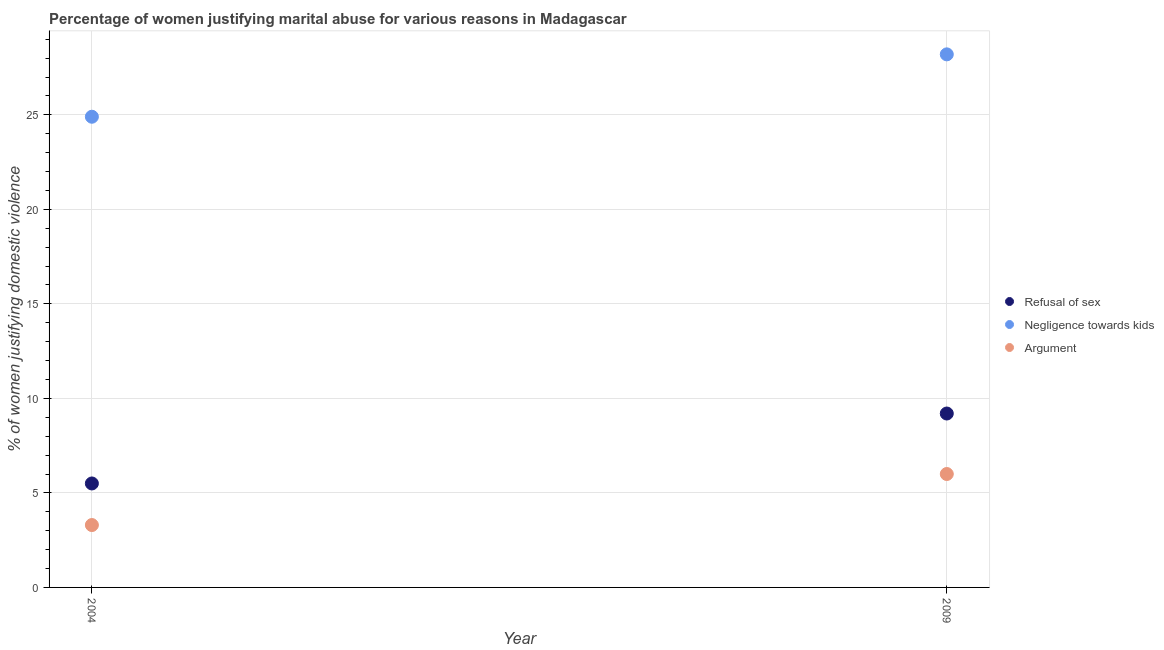How many different coloured dotlines are there?
Keep it short and to the point. 3. Is the number of dotlines equal to the number of legend labels?
Your answer should be very brief. Yes. What is the percentage of women justifying domestic violence due to arguments in 2004?
Offer a terse response. 3.3. Across all years, what is the minimum percentage of women justifying domestic violence due to refusal of sex?
Provide a short and direct response. 5.5. In which year was the percentage of women justifying domestic violence due to negligence towards kids minimum?
Provide a succinct answer. 2004. What is the total percentage of women justifying domestic violence due to negligence towards kids in the graph?
Provide a short and direct response. 53.1. What is the difference between the percentage of women justifying domestic violence due to negligence towards kids in 2004 and that in 2009?
Provide a succinct answer. -3.3. What is the average percentage of women justifying domestic violence due to negligence towards kids per year?
Offer a terse response. 26.55. In the year 2004, what is the difference between the percentage of women justifying domestic violence due to arguments and percentage of women justifying domestic violence due to negligence towards kids?
Give a very brief answer. -21.6. In how many years, is the percentage of women justifying domestic violence due to arguments greater than 23 %?
Ensure brevity in your answer.  0. What is the ratio of the percentage of women justifying domestic violence due to negligence towards kids in 2004 to that in 2009?
Provide a short and direct response. 0.88. Is the percentage of women justifying domestic violence due to refusal of sex strictly less than the percentage of women justifying domestic violence due to negligence towards kids over the years?
Give a very brief answer. Yes. How many dotlines are there?
Ensure brevity in your answer.  3. What is the difference between two consecutive major ticks on the Y-axis?
Provide a succinct answer. 5. Are the values on the major ticks of Y-axis written in scientific E-notation?
Your response must be concise. No. Does the graph contain grids?
Keep it short and to the point. Yes. How many legend labels are there?
Give a very brief answer. 3. What is the title of the graph?
Offer a very short reply. Percentage of women justifying marital abuse for various reasons in Madagascar. Does "Hydroelectric sources" appear as one of the legend labels in the graph?
Offer a very short reply. No. What is the label or title of the X-axis?
Offer a very short reply. Year. What is the label or title of the Y-axis?
Provide a short and direct response. % of women justifying domestic violence. What is the % of women justifying domestic violence of Negligence towards kids in 2004?
Offer a terse response. 24.9. What is the % of women justifying domestic violence of Argument in 2004?
Your answer should be compact. 3.3. What is the % of women justifying domestic violence in Refusal of sex in 2009?
Your answer should be compact. 9.2. What is the % of women justifying domestic violence of Negligence towards kids in 2009?
Ensure brevity in your answer.  28.2. What is the % of women justifying domestic violence in Argument in 2009?
Provide a short and direct response. 6. Across all years, what is the maximum % of women justifying domestic violence of Refusal of sex?
Offer a very short reply. 9.2. Across all years, what is the maximum % of women justifying domestic violence of Negligence towards kids?
Offer a terse response. 28.2. Across all years, what is the minimum % of women justifying domestic violence in Negligence towards kids?
Keep it short and to the point. 24.9. What is the total % of women justifying domestic violence of Negligence towards kids in the graph?
Keep it short and to the point. 53.1. What is the difference between the % of women justifying domestic violence in Argument in 2004 and that in 2009?
Provide a succinct answer. -2.7. What is the difference between the % of women justifying domestic violence of Refusal of sex in 2004 and the % of women justifying domestic violence of Negligence towards kids in 2009?
Your answer should be very brief. -22.7. What is the difference between the % of women justifying domestic violence of Negligence towards kids in 2004 and the % of women justifying domestic violence of Argument in 2009?
Give a very brief answer. 18.9. What is the average % of women justifying domestic violence of Refusal of sex per year?
Provide a succinct answer. 7.35. What is the average % of women justifying domestic violence of Negligence towards kids per year?
Provide a succinct answer. 26.55. What is the average % of women justifying domestic violence of Argument per year?
Make the answer very short. 4.65. In the year 2004, what is the difference between the % of women justifying domestic violence of Refusal of sex and % of women justifying domestic violence of Negligence towards kids?
Make the answer very short. -19.4. In the year 2004, what is the difference between the % of women justifying domestic violence of Negligence towards kids and % of women justifying domestic violence of Argument?
Make the answer very short. 21.6. In the year 2009, what is the difference between the % of women justifying domestic violence of Refusal of sex and % of women justifying domestic violence of Negligence towards kids?
Your answer should be compact. -19. In the year 2009, what is the difference between the % of women justifying domestic violence in Negligence towards kids and % of women justifying domestic violence in Argument?
Offer a very short reply. 22.2. What is the ratio of the % of women justifying domestic violence of Refusal of sex in 2004 to that in 2009?
Your response must be concise. 0.6. What is the ratio of the % of women justifying domestic violence in Negligence towards kids in 2004 to that in 2009?
Give a very brief answer. 0.88. What is the ratio of the % of women justifying domestic violence in Argument in 2004 to that in 2009?
Your answer should be compact. 0.55. What is the difference between the highest and the second highest % of women justifying domestic violence of Refusal of sex?
Make the answer very short. 3.7. What is the difference between the highest and the second highest % of women justifying domestic violence in Negligence towards kids?
Provide a succinct answer. 3.3. What is the difference between the highest and the lowest % of women justifying domestic violence of Negligence towards kids?
Give a very brief answer. 3.3. 